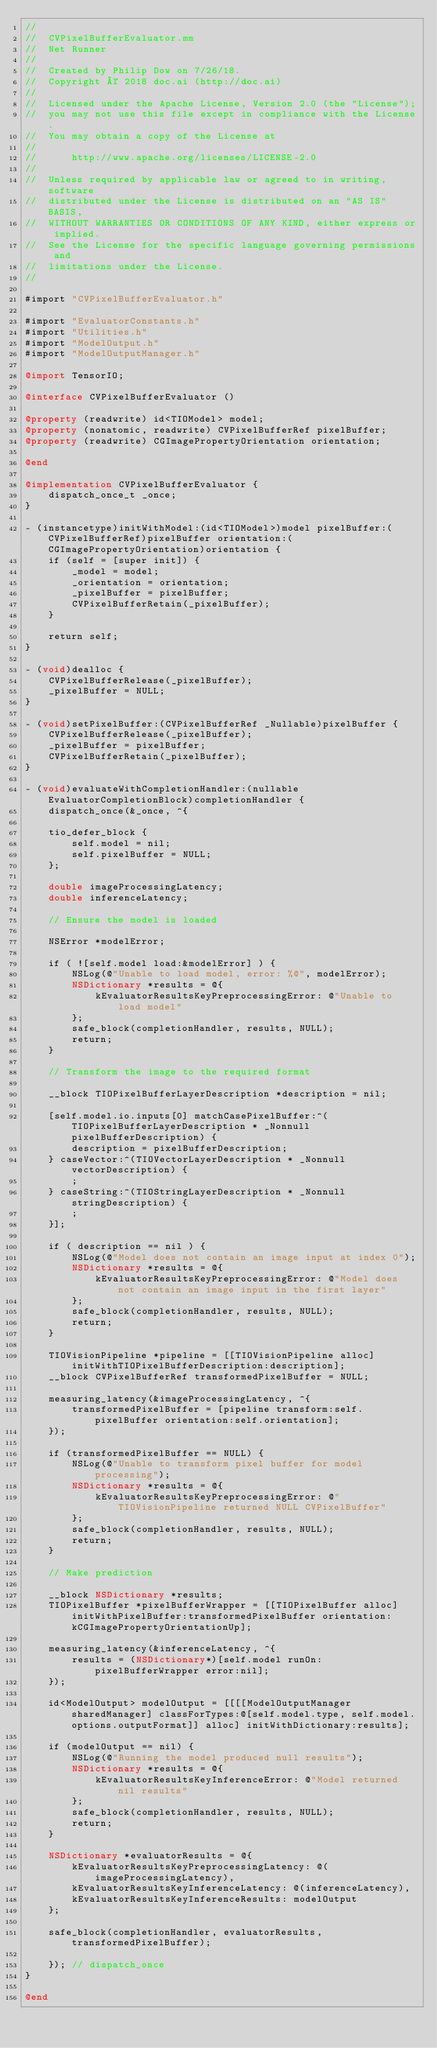<code> <loc_0><loc_0><loc_500><loc_500><_ObjectiveC_>//
//  CVPixelBufferEvaluator.mm
//  Net Runner
//
//  Created by Philip Dow on 7/26/18.
//  Copyright © 2018 doc.ai (http://doc.ai)
//
//  Licensed under the Apache License, Version 2.0 (the "License");
//  you may not use this file except in compliance with the License.
//  You may obtain a copy of the License at
//
//      http://www.apache.org/licenses/LICENSE-2.0
//
//  Unless required by applicable law or agreed to in writing, software
//  distributed under the License is distributed on an "AS IS" BASIS,
//  WITHOUT WARRANTIES OR CONDITIONS OF ANY KIND, either express or implied.
//  See the License for the specific language governing permissions and
//  limitations under the License.
//

#import "CVPixelBufferEvaluator.h"

#import "EvaluatorConstants.h"
#import "Utilities.h"
#import "ModelOutput.h"
#import "ModelOutputManager.h"

@import TensorIO;

@interface CVPixelBufferEvaluator ()

@property (readwrite) id<TIOModel> model;
@property (nonatomic, readwrite) CVPixelBufferRef pixelBuffer;
@property (readwrite) CGImagePropertyOrientation orientation;

@end

@implementation CVPixelBufferEvaluator {
    dispatch_once_t _once;
}

- (instancetype)initWithModel:(id<TIOModel>)model pixelBuffer:(CVPixelBufferRef)pixelBuffer orientation:(CGImagePropertyOrientation)orientation {
    if (self = [super init]) {
        _model = model;
        _orientation = orientation;
        _pixelBuffer = pixelBuffer;
        CVPixelBufferRetain(_pixelBuffer);
    }
    
    return self;
}

- (void)dealloc {
    CVPixelBufferRelease(_pixelBuffer);
    _pixelBuffer = NULL;
}

- (void)setPixelBuffer:(CVPixelBufferRef _Nullable)pixelBuffer {
    CVPixelBufferRelease(_pixelBuffer);
    _pixelBuffer = pixelBuffer;
    CVPixelBufferRetain(_pixelBuffer);
}

- (void)evaluateWithCompletionHandler:(nullable EvaluatorCompletionBlock)completionHandler {
    dispatch_once(&_once, ^{
    
    tio_defer_block {
        self.model = nil;
        self.pixelBuffer = NULL;
    };
    
    double imageProcessingLatency;
    double inferenceLatency;
    
    // Ensure the model is loaded
    
    NSError *modelError;
    
    if ( ![self.model load:&modelError] ) {
        NSLog(@"Unable to load model, error: %@", modelError);
        NSDictionary *results = @{
            kEvaluatorResultsKeyPreprocessingError: @"Unable to load model"
        };
        safe_block(completionHandler, results, NULL);
        return;
    }
    
    // Transform the image to the required format
    
    __block TIOPixelBufferLayerDescription *description = nil;
    
    [self.model.io.inputs[0] matchCasePixelBuffer:^(TIOPixelBufferLayerDescription * _Nonnull pixelBufferDescription) {
        description = pixelBufferDescription;
    } caseVector:^(TIOVectorLayerDescription * _Nonnull vectorDescription) {
        ;
    } caseString:^(TIOStringLayerDescription * _Nonnull stringDescription) {
        ;
    }];
    
    if ( description == nil ) {
        NSLog(@"Model does not contain an image input at index 0");
        NSDictionary *results = @{
            kEvaluatorResultsKeyPreprocessingError: @"Model does not contain an image input in the first layer"
        };
        safe_block(completionHandler, results, NULL);
        return;
    }
    
    TIOVisionPipeline *pipeline = [[TIOVisionPipeline alloc] initWithTIOPixelBufferDescription:description];
    __block CVPixelBufferRef transformedPixelBuffer = NULL;
    
    measuring_latency(&imageProcessingLatency, ^{
        transformedPixelBuffer = [pipeline transform:self.pixelBuffer orientation:self.orientation];
    });
    
    if (transformedPixelBuffer == NULL) {
        NSLog(@"Unable to transform pixel buffer for model processing");
        NSDictionary *results = @{
            kEvaluatorResultsKeyPreprocessingError: @"TIOVisionPipeline returned NULL CVPixelBuffer"
        };
        safe_block(completionHandler, results, NULL);
        return;
    }
    
    // Make prediction
    
    __block NSDictionary *results;
    TIOPixelBuffer *pixelBufferWrapper = [[TIOPixelBuffer alloc] initWithPixelBuffer:transformedPixelBuffer orientation:kCGImagePropertyOrientationUp];
    
    measuring_latency(&inferenceLatency, ^{
        results = (NSDictionary*)[self.model runOn:pixelBufferWrapper error:nil];
    });
    
    id<ModelOutput> modelOutput = [[[[ModelOutputManager sharedManager] classForTypes:@[self.model.type, self.model.options.outputFormat]] alloc] initWithDictionary:results];
    
    if (modelOutput == nil) {
        NSLog(@"Running the model produced null results");
        NSDictionary *results = @{
            kEvaluatorResultsKeyInferenceError: @"Model returned nil results"
        };
        safe_block(completionHandler, results, NULL);
        return;
    }
    
    NSDictionary *evaluatorResults = @{
        kEvaluatorResultsKeyPreprocessingLatency: @(imageProcessingLatency),
        kEvaluatorResultsKeyInferenceLatency: @(inferenceLatency),
        kEvaluatorResultsKeyInferenceResults: modelOutput
    };
    
    safe_block(completionHandler, evaluatorResults, transformedPixelBuffer);
    
    }); // dispatch_once
}

@end
</code> 